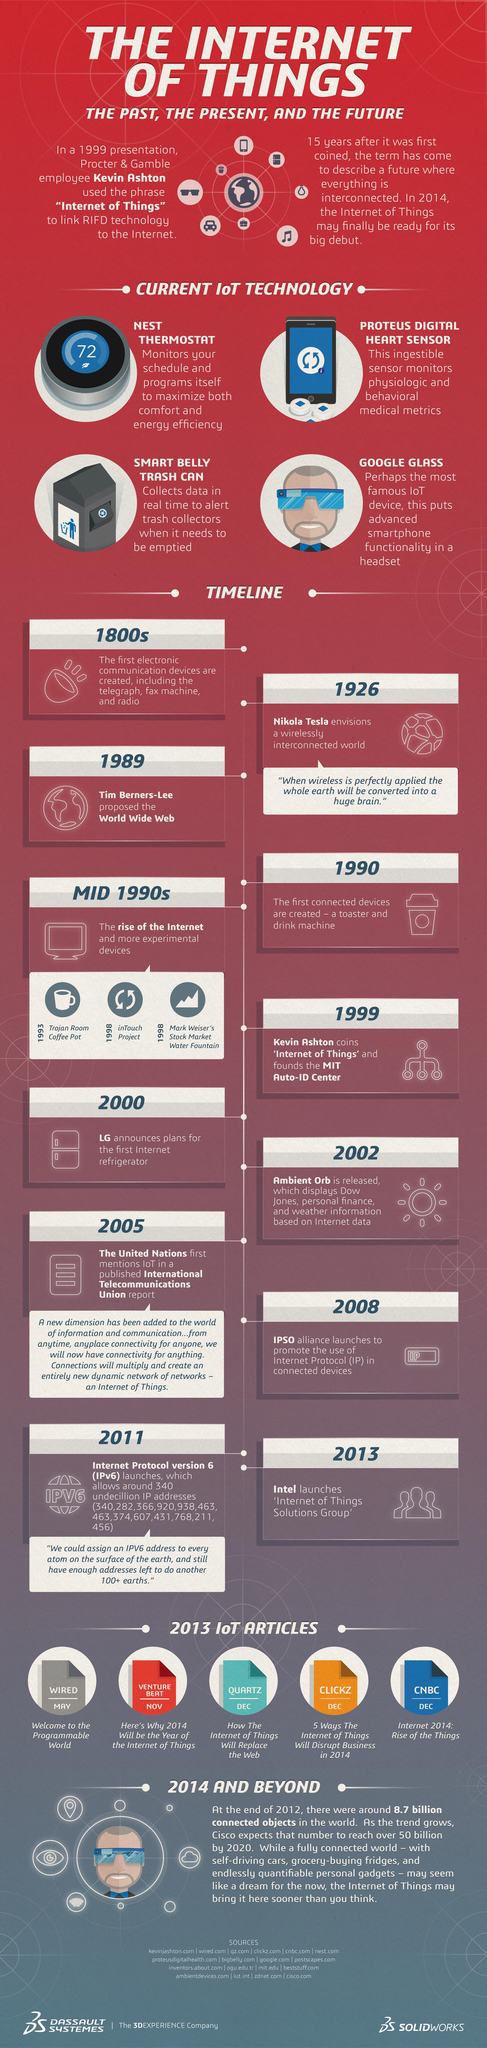Give some essential details in this illustration. This infographic mentions 13 unique IP addresses. The launch of Internet Protocol Version 6 occurred in 2011. The most well-known IoT device is Google Glass. The telegraph, invented in the 1800s, was a groundbreaking communication device that revolutionized the way people exchanged information and ideas. This infographic mentions 5 IoT articles. 